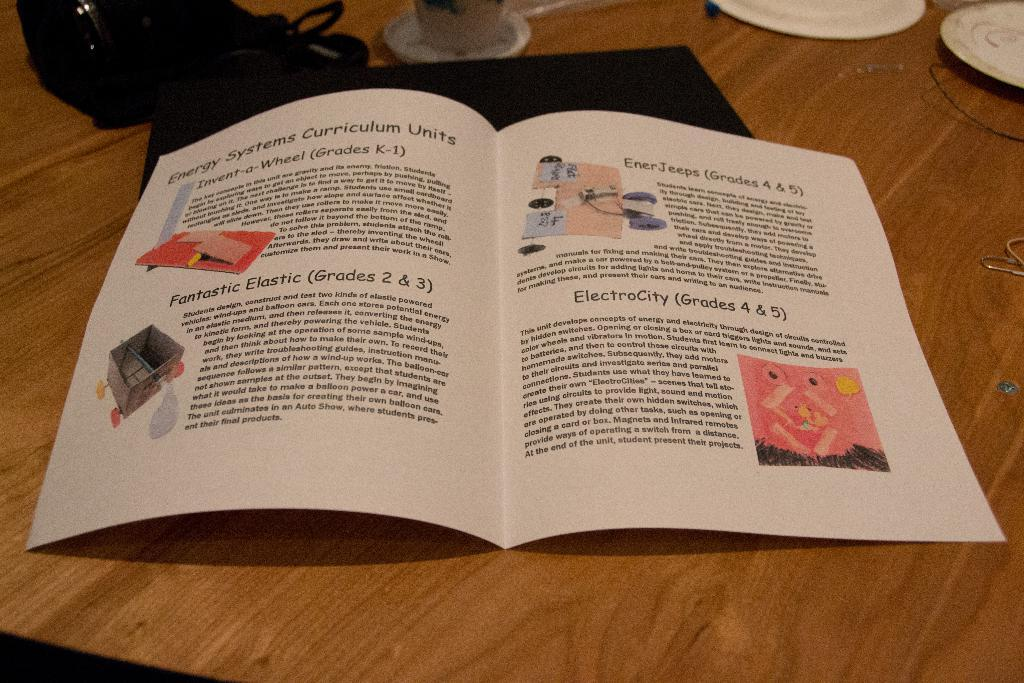<image>
Relay a brief, clear account of the picture shown. a paper with a lot of information about energy systems is laying on a table 